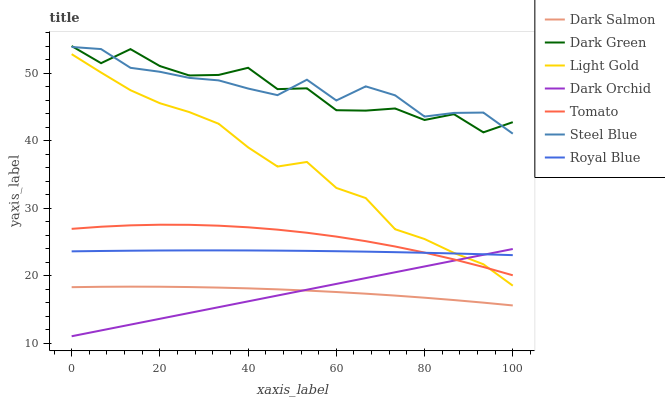Does Steel Blue have the minimum area under the curve?
Answer yes or no. No. Does Dark Orchid have the maximum area under the curve?
Answer yes or no. No. Is Steel Blue the smoothest?
Answer yes or no. No. Is Steel Blue the roughest?
Answer yes or no. No. Does Steel Blue have the lowest value?
Answer yes or no. No. Does Steel Blue have the highest value?
Answer yes or no. No. Is Dark Orchid less than Dark Green?
Answer yes or no. Yes. Is Dark Green greater than Light Gold?
Answer yes or no. Yes. Does Dark Orchid intersect Dark Green?
Answer yes or no. No. 